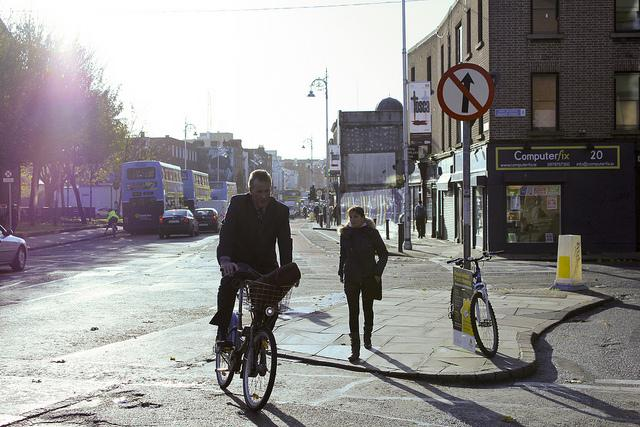Where is the man on the bicycle possibly going?

Choices:
A) work
B) school
C) gym
D) wedding work 